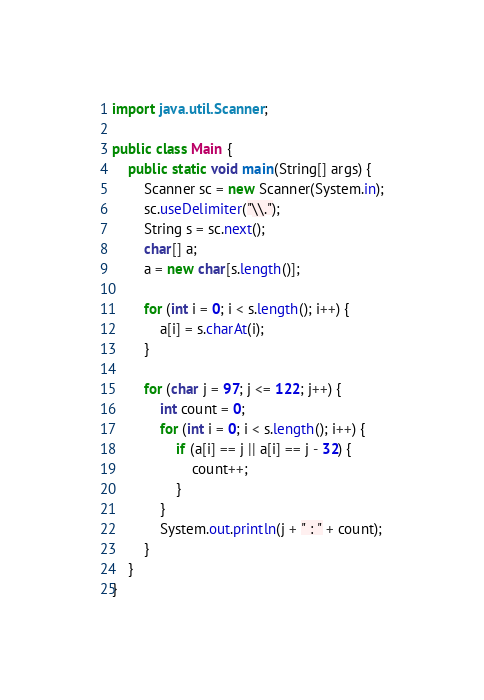<code> <loc_0><loc_0><loc_500><loc_500><_Java_>import java.util.Scanner;

public class Main {
	public static void main(String[] args) {
		Scanner sc = new Scanner(System.in);
		sc.useDelimiter("\\.");
		String s = sc.next();
		char[] a;
		a = new char[s.length()];

		for (int i = 0; i < s.length(); i++) {
			a[i] = s.charAt(i);
		}

		for (char j = 97; j <= 122; j++) {
			int count = 0;
			for (int i = 0; i < s.length(); i++) {
				if (a[i] == j || a[i] == j - 32) {
					count++;
				}
			}
			System.out.println(j + " : " + count);
		}
	}
}</code> 